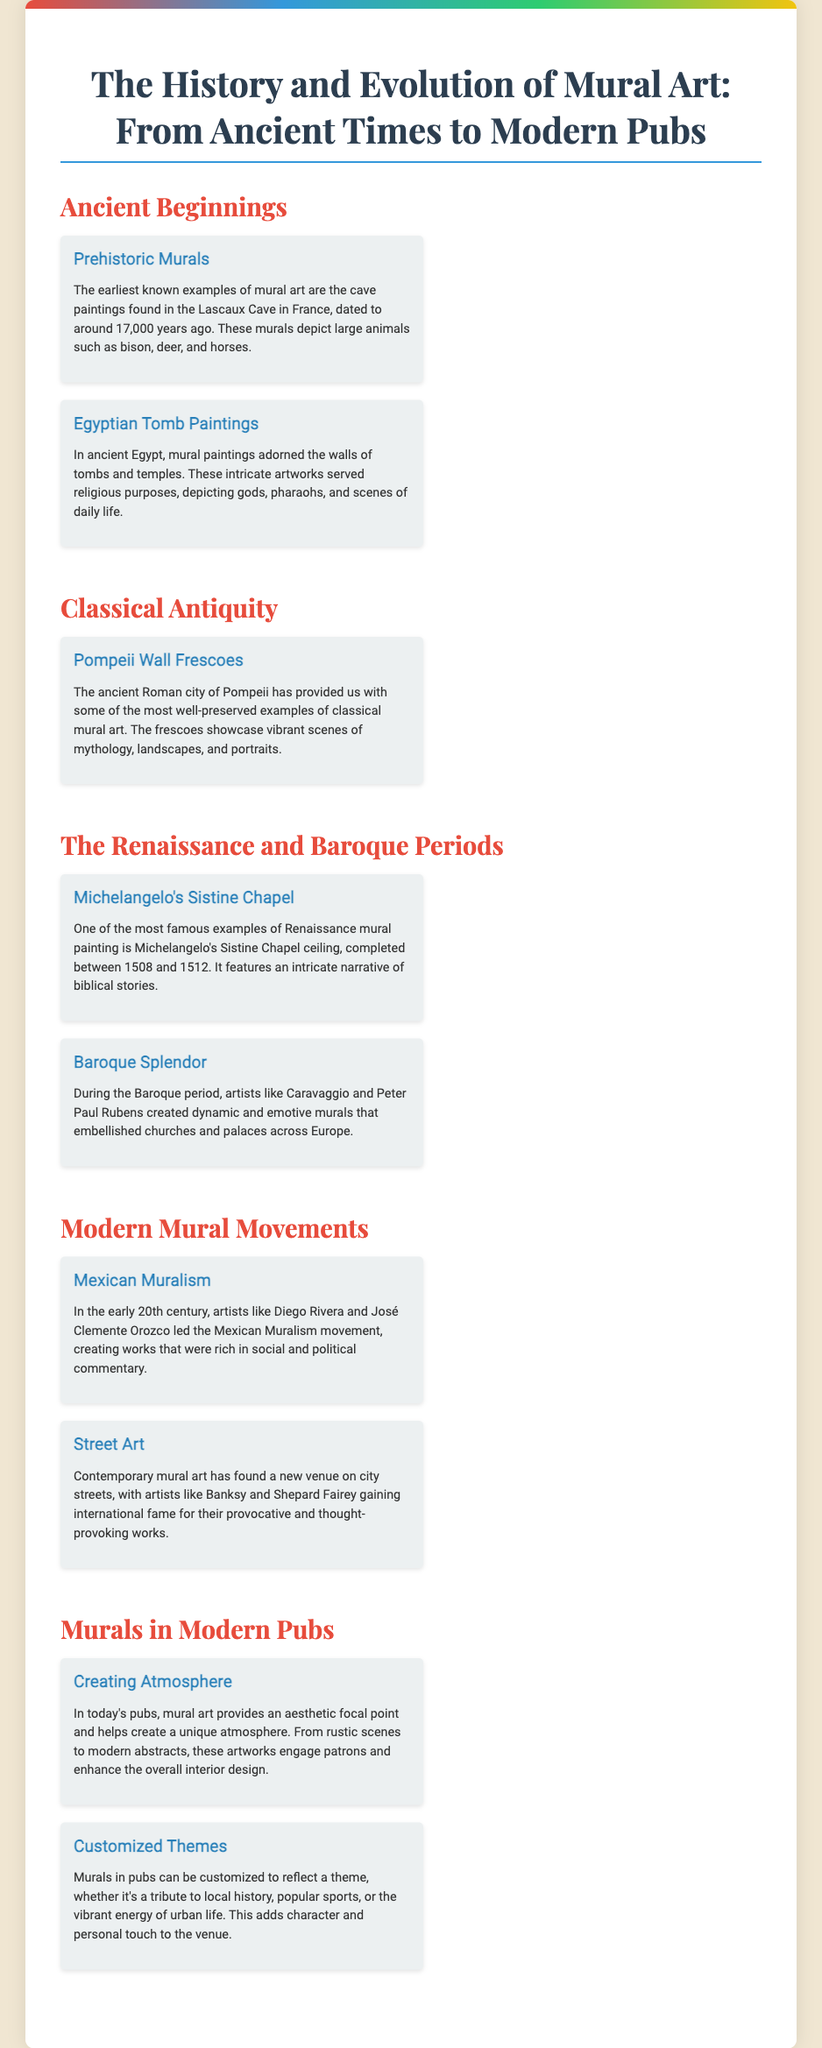What are the earliest known examples of mural art? The document states that the earliest known examples of mural art are the cave paintings found in Lascaux Cave, which depict large animals.
Answer: Lascaux Cave When were Egyptian tomb paintings created? Egyptian tomb paintings adorned the walls of tombs and temples, serving religious purposes, as mentioned in the document, but a specific date is not provided.
Answer: Ancient times Which city provides well-preserved examples of classical mural art? The document notes that the ancient Roman city of Pompeii has provided some of the most well-preserved examples of classical mural art.
Answer: Pompeii Who completed the Sistine Chapel ceiling? According to the document, Michelangelo is the artist who completed the Sistine Chapel ceiling.
Answer: Michelangelo What movement did Diego Rivera belong to? The document mentions that Diego Rivera led the Mexican Muralism movement in the early 20th century.
Answer: Mexican Muralism How do modern murals enhance the interior design of pubs? The document explains that mural art provides an aesthetic focal point and helps create a unique atmosphere in pubs.
Answer: Aesthetic focal point What themes can be reflected in pub murals? The document states that murals in pubs can reflect a variety of themes such as local history or popular sports.
Answer: Customized themes 